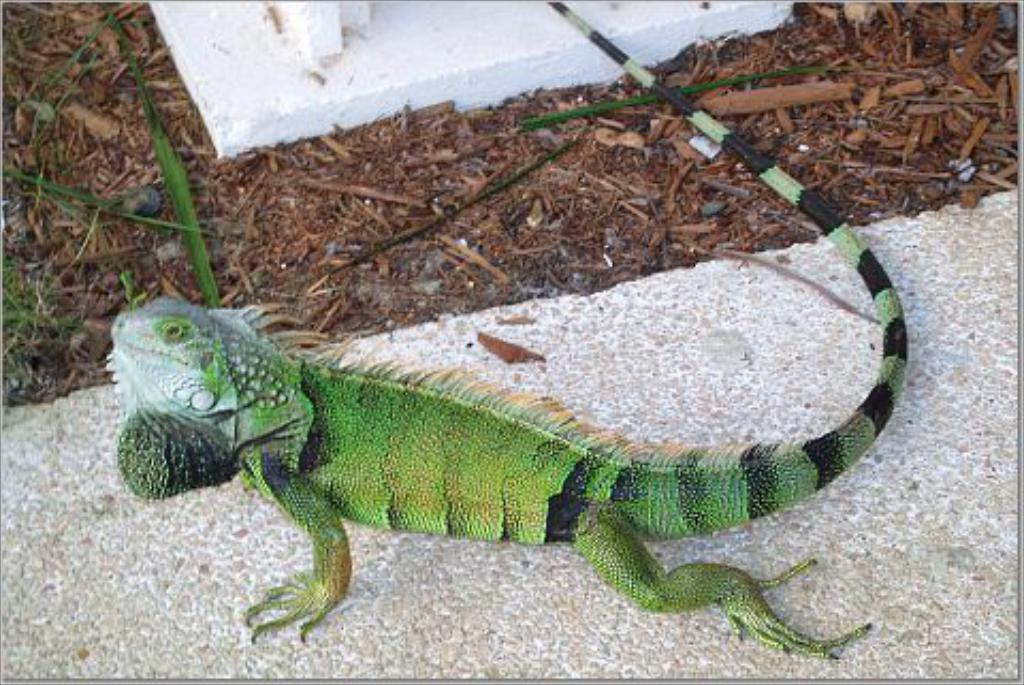What type of animal can be seen on the wall in the image? There is a gecko on the wall in the image. What is present on the floor in the image? There are dry leaves and wooden sticks on the floor in the image. What type of meat is being served by the servant in the image? There is no servant or meat present in the image; it features a gecko on the wall and dry leaves and wooden sticks on the floor. What type of wax is visible on the floor in the image? There is no wax present in the image; it features a gecko on the wall and dry leaves and wooden sticks on the floor. 